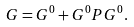Convert formula to latex. <formula><loc_0><loc_0><loc_500><loc_500>G = G ^ { 0 } + G ^ { 0 } P G ^ { 0 } .</formula> 